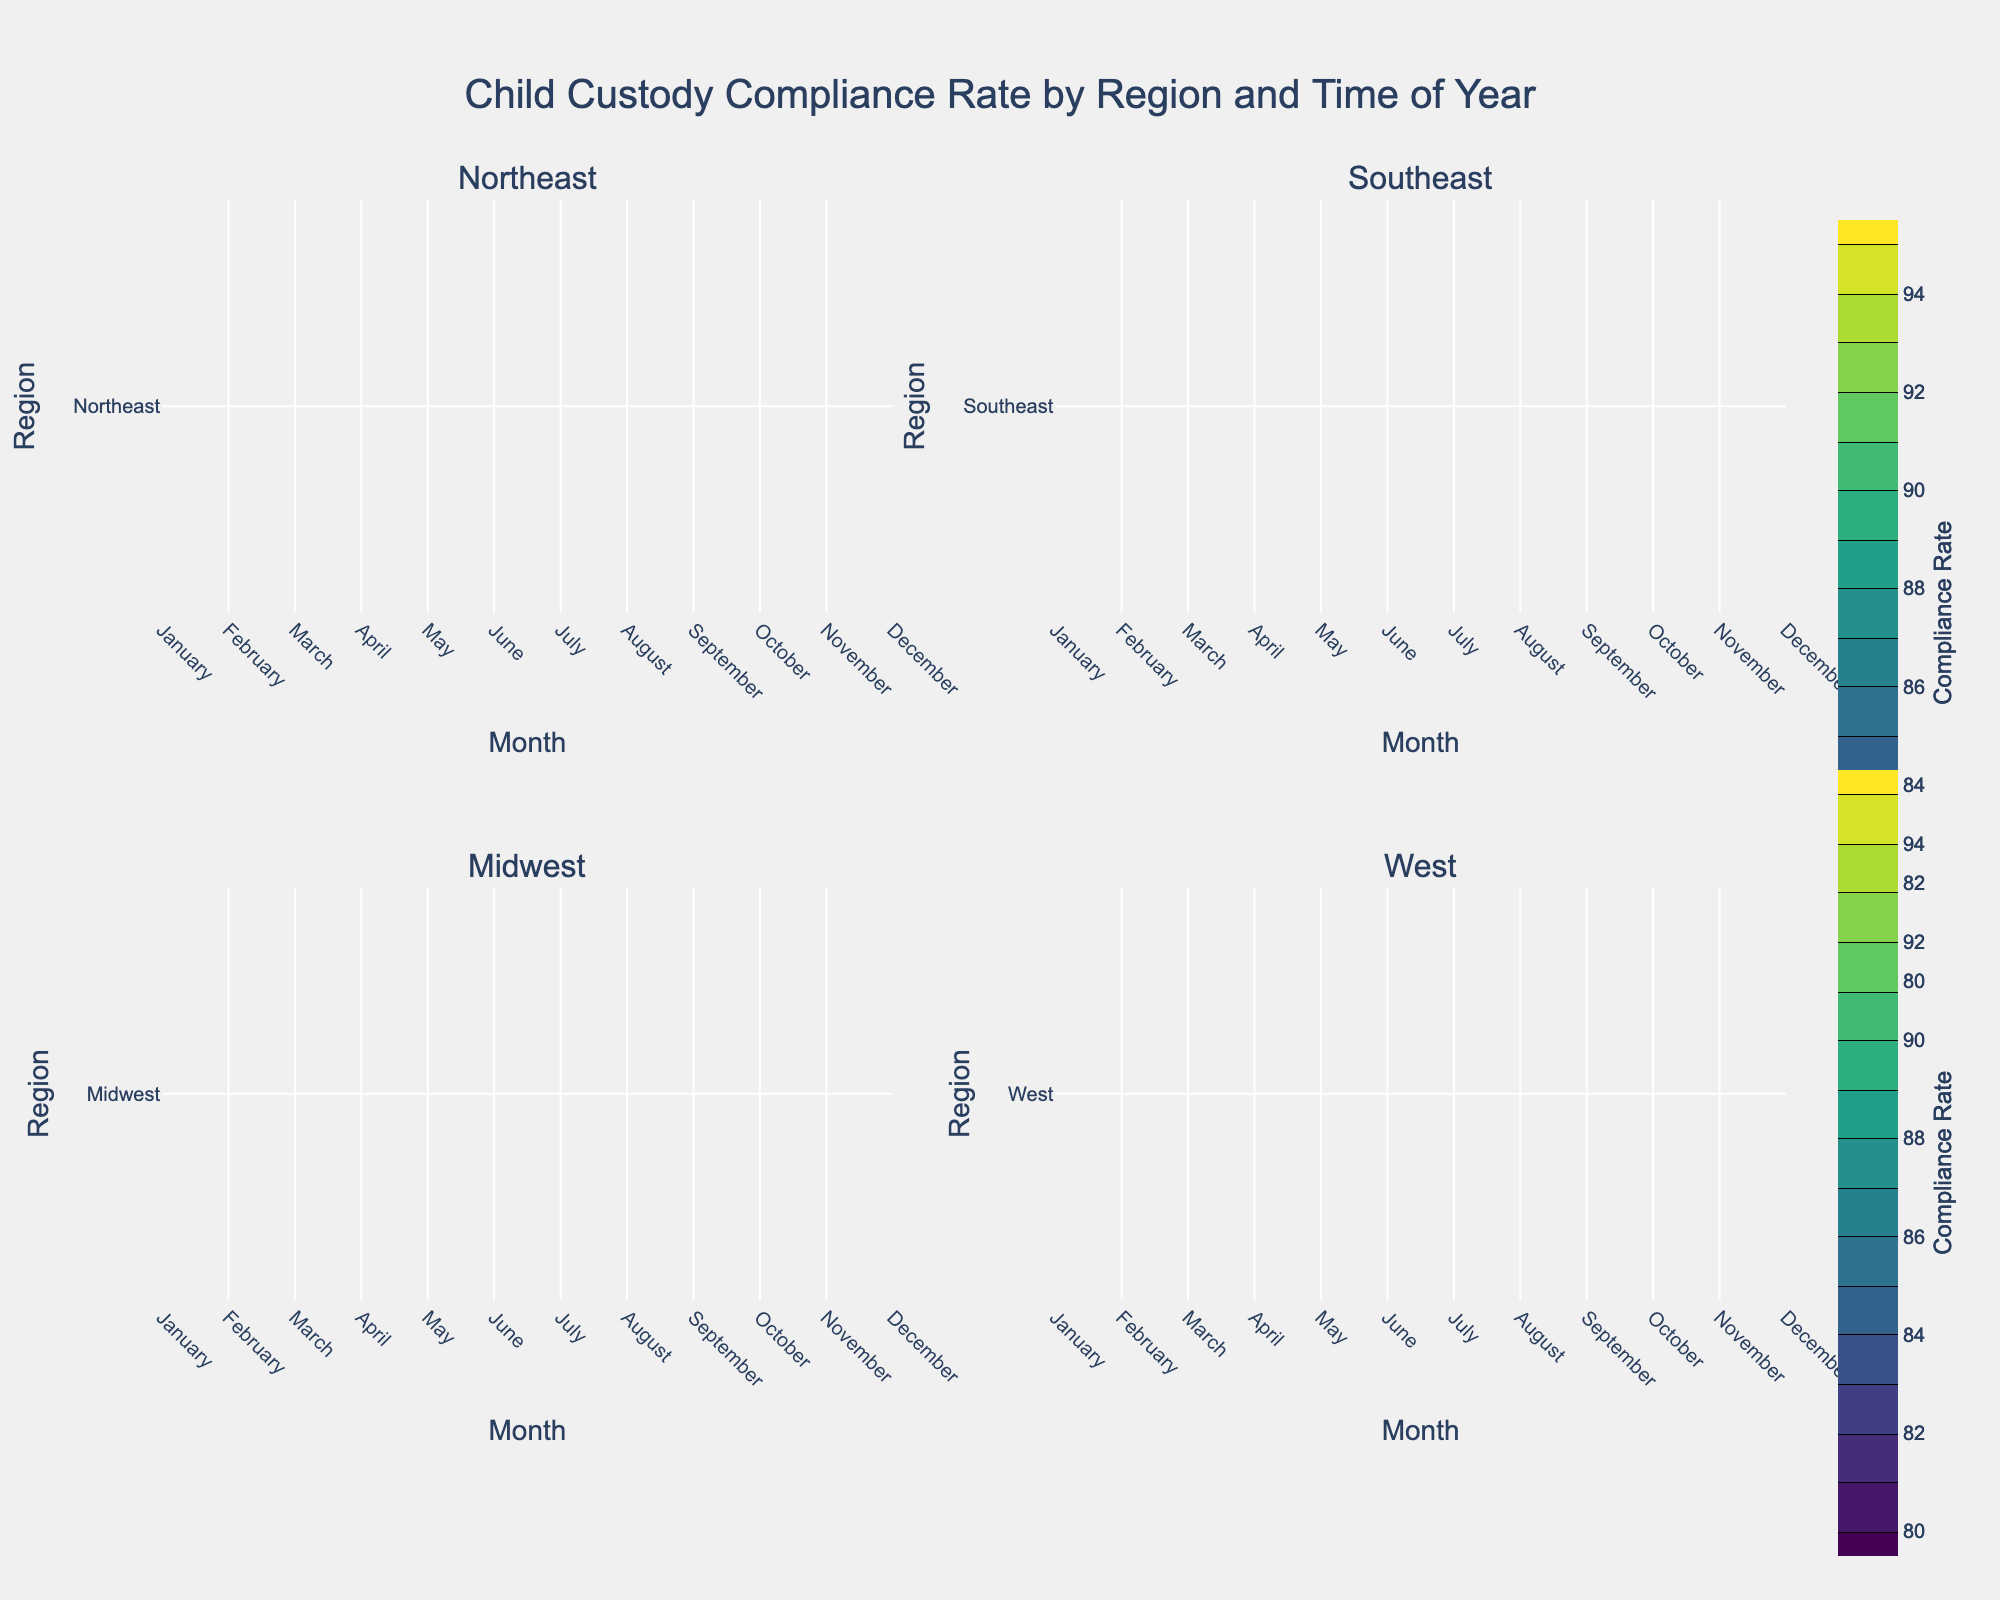What is the title of the figure? The title of the figure is located at the top-center of the chart. It provides an overview of what the figure represents.
Answer: Child Custody Compliance Rate by Region and Time of Year Which month shows the highest compliance rate in the Northeast region? In the Northeast subplot, the contour labels indicate the highest compliance rate. Look for the highest number on the contour.
Answer: May How does the compliance rate in the Midwest region during June compare to July? Compare the contour labels for the Midwest region during June and July. Identify which month shows a higher compliance rate based on the numbers in the contour plot.
Answer: The compliance rate in June is higher than in July What is the range of compliance rates in the West region? Identify the lowest and highest contour values in the West subplot to determine the range.
Answer: 85 to 92 Which region exhibits the most fluctuation in compliance rates throughout the year? Observe the spread and variation in the contour lines for each region. The region with the most variable contour lines has the most fluctuation.
Answer: Southeast Is the compliance rate generally higher in the Northeast or the Southeast during the spring months (March-May)? Look at the contour labels for the Northeast and Southeast subplots during March to May. Compare the values.
Answer: Northeast Identify one month where the Midwest and West regions have the same compliance rate. Find a month where the contour labels for both the Midwest and West regions match.
Answer: February What is the lowest compliance rate recorded in the Southeast region, and in which month does it occur? Check the Southeast subplot for the lowest contour value and note the corresponding month.
Answer: 82 in December During which season (Winter, Spring, Summer, or Fall) does the Midwest region show the most consistent compliance rates? Examine the Midwest subplot and see in which season the contour lines are closest together, indicating consistent rates.
Answer: Summer Does the compliance rate in the West region peak during the same month as in the Northeast region? Compare the peak compliance rate months in both the West and Northeast subplots.
Answer: No 